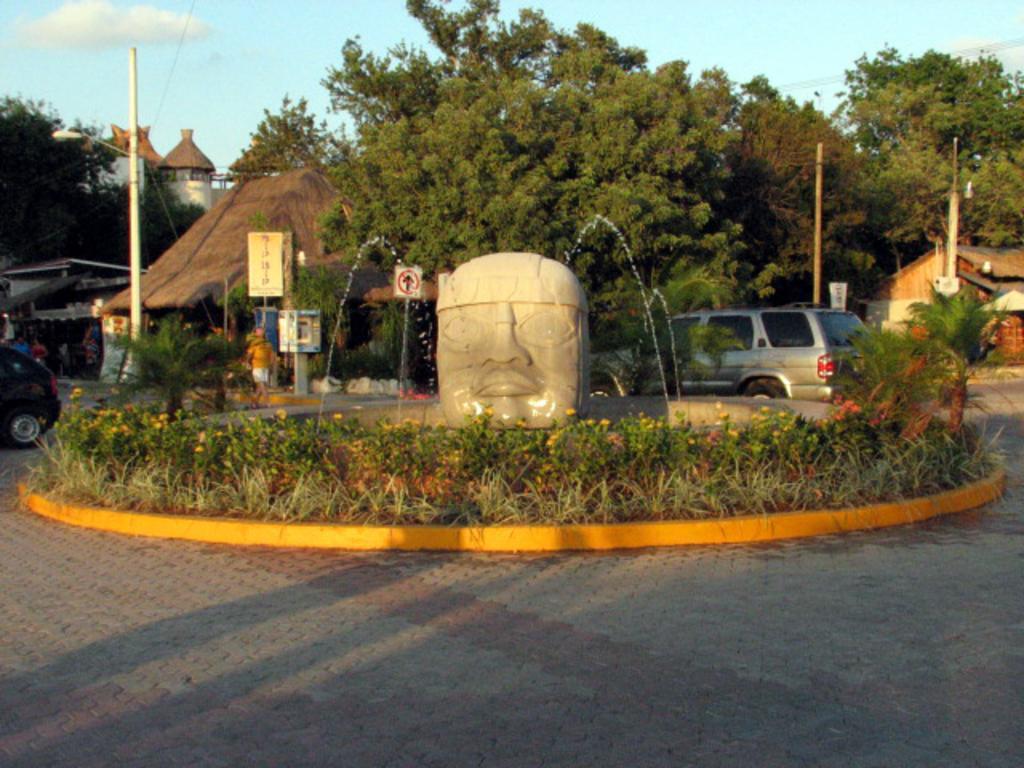Could you give a brief overview of what you see in this image? In this image in the center there are plants and there is a sculpture. In the background there are trees, vehicles, houses, boards, poles and the sky is cloudy and there is a fountain in the center. 